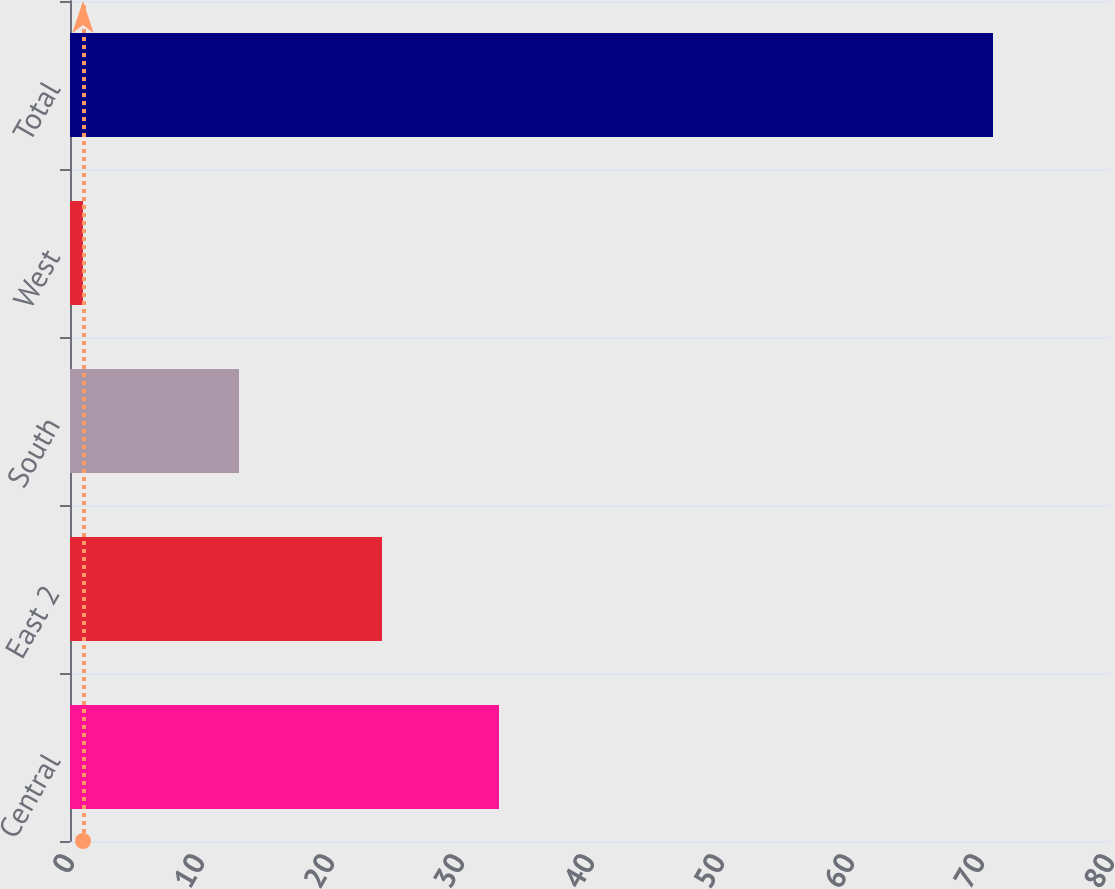<chart> <loc_0><loc_0><loc_500><loc_500><bar_chart><fcel>Central<fcel>East 2<fcel>South<fcel>West<fcel>Total<nl><fcel>33<fcel>24<fcel>13<fcel>1<fcel>71<nl></chart> 